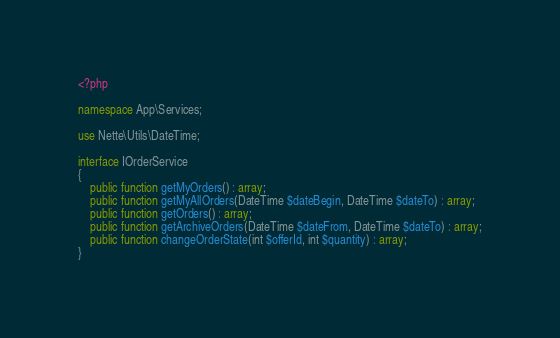Convert code to text. <code><loc_0><loc_0><loc_500><loc_500><_PHP_><?php

namespace App\Services;

use Nette\Utils\DateTime;

interface IOrderService
{
    public function getMyOrders() : array;
    public function getMyAllOrders(DateTime $dateBegin, DateTime $dateTo) : array;
    public function getOrders() : array;
    public function getArchiveOrders(DateTime $dateFrom, DateTime $dateTo) : array;
    public function changeOrderState(int $offerId, int $quantity) : array;
}
</code> 